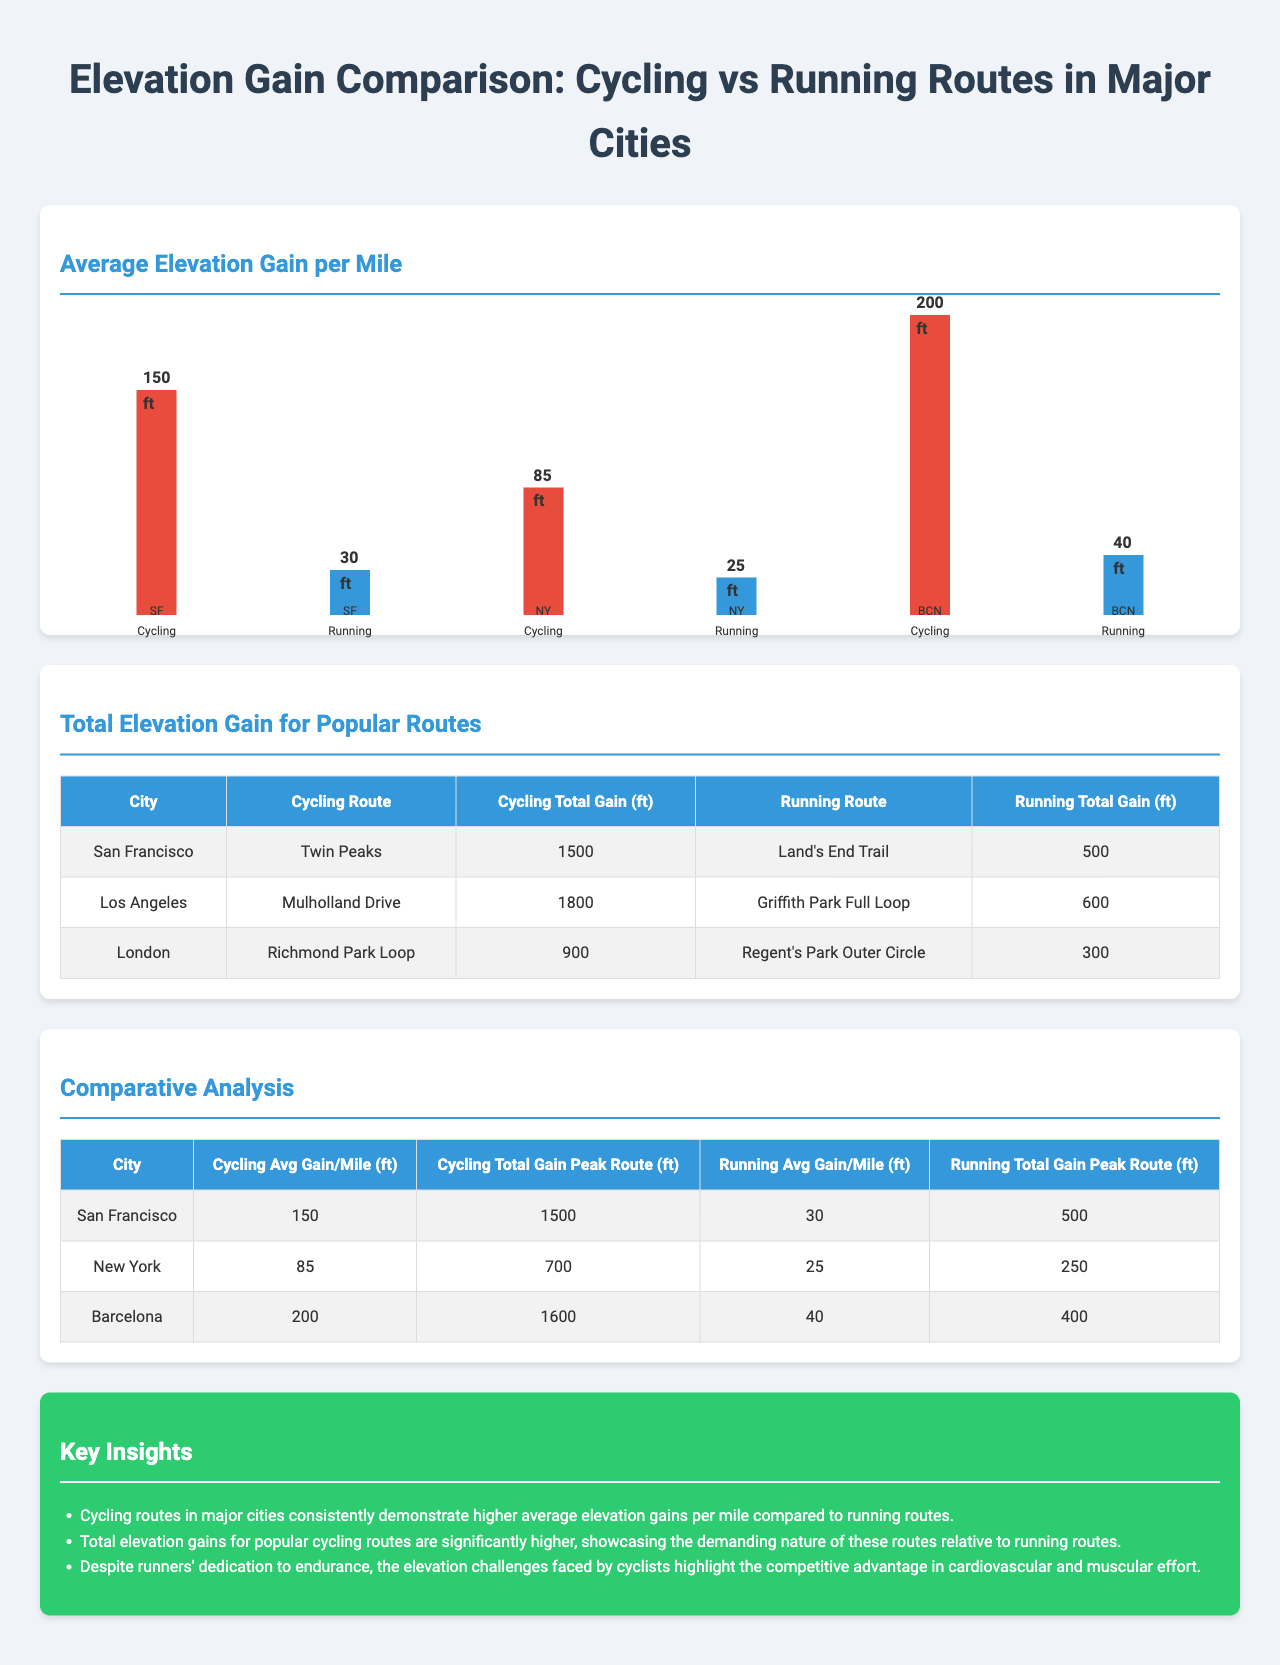what is the average elevation gain per mile for cycling in San Francisco? The average elevation gain per mile for cycling in San Francisco is listed in the chart as 150 ft.
Answer: 150 ft what is the total elevation gain for the cycling route in Los Angeles? The total elevation gain for the cycling route Mulholland Drive in Los Angeles is found in the comparison table and is 1800 ft.
Answer: 1800 ft which city has the highest average elevation gain per mile for cycling? By comparing the average elevation gains listed, Barcelona has the highest average elevation gain per mile for cycling at 200 ft.
Answer: 200 ft how much total elevation gain do runners experience on the Land's End Trail in San Francisco? The total elevation gain for the running route Land's End Trail in San Francisco is provided in the comparison table and is 500 ft.
Answer: 500 ft what percentage higher is the cycling average elevation gain per mile in Barcelona compared to New York? The comparison of elevation gains per mile shows Barcelona at 200 ft and New York at 85 ft, making it 115 ft higher, which is approximately 135% more.
Answer: 135% what is the running total gain for the Richmond Park Loop in London? The running total gain for the Richmond Park Loop is specified in the comparison table and it is 300 ft.
Answer: 300 ft what is a key insight regarding the elevation challenges faced by cyclists? One of the key insights states that cycling routes demonstrate significantly higher total elevation gains compared to running routes, emphasizing the greater demands placed on cyclists.
Answer: Higher total elevation gains how many cities are compared in terms of cycling and running routes? The document provides comparative analysis for three cities: San Francisco, New York, and Barcelona.
Answer: Three cities 